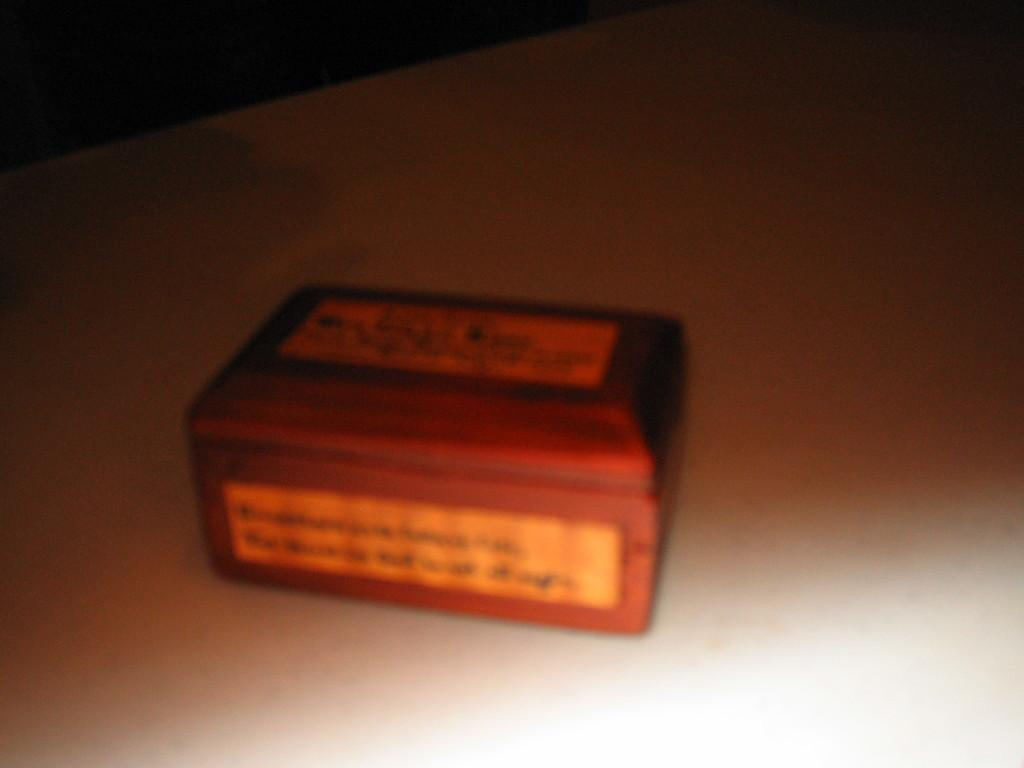What is the main object in the center of the image? There is a box in the center of the image. What type of surface is visible at the bottom of the image? There is a floor visible at the bottom of the image. What committee is meeting in the image? There is no committee meeting in the image; it only features a box and a floor. Is there a volcano visible in the image? No, there is no volcano present in the image. 